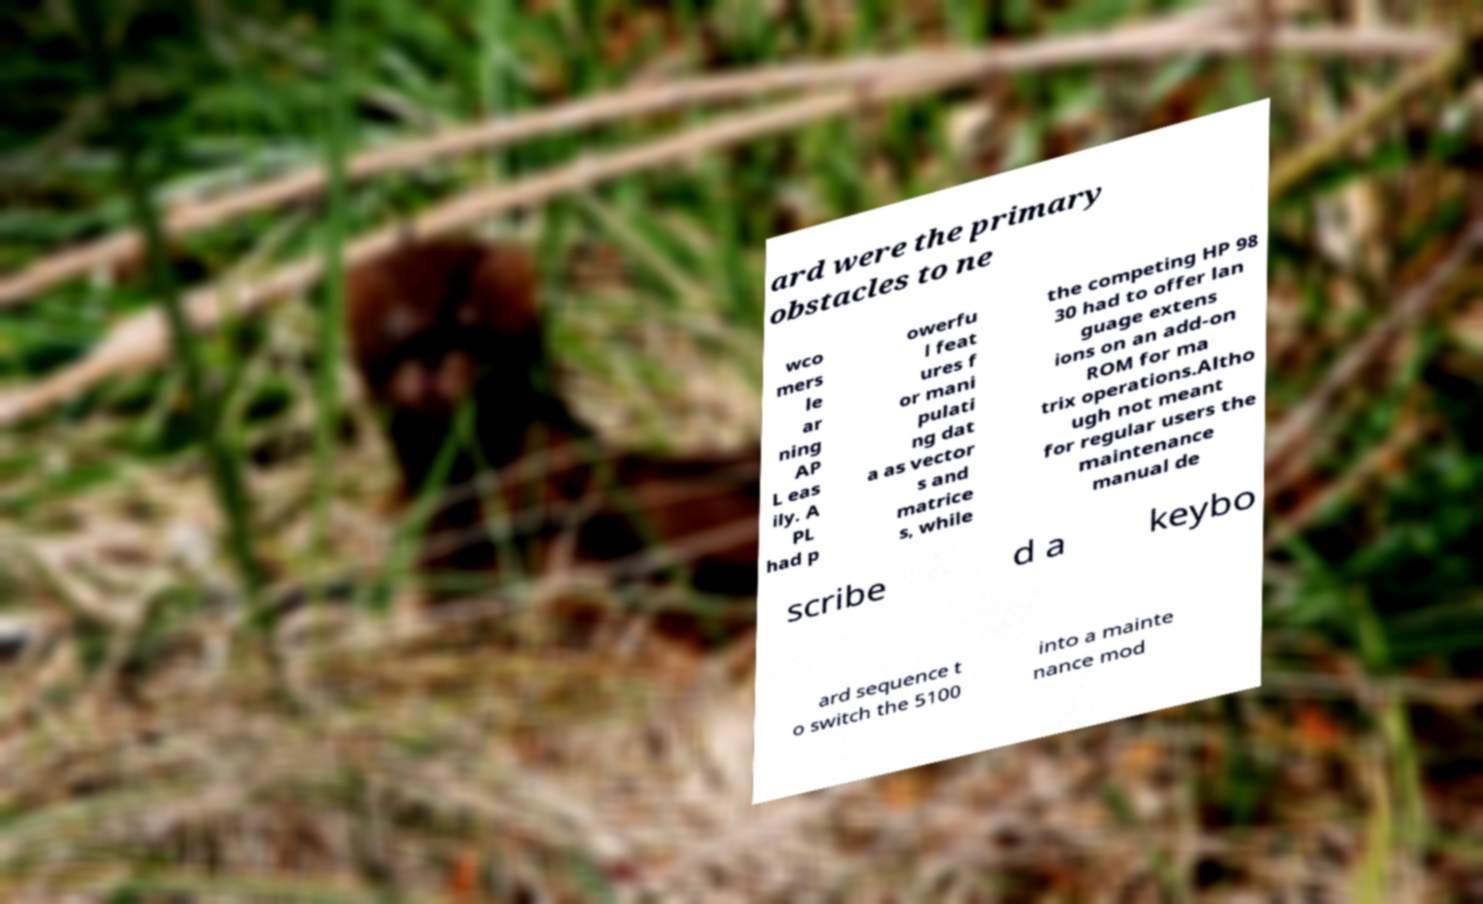Could you assist in decoding the text presented in this image and type it out clearly? ard were the primary obstacles to ne wco mers le ar ning AP L eas ily. A PL had p owerfu l feat ures f or mani pulati ng dat a as vector s and matrice s, while the competing HP 98 30 had to offer lan guage extens ions on an add-on ROM for ma trix operations.Altho ugh not meant for regular users the maintenance manual de scribe d a keybo ard sequence t o switch the 5100 into a mainte nance mod 